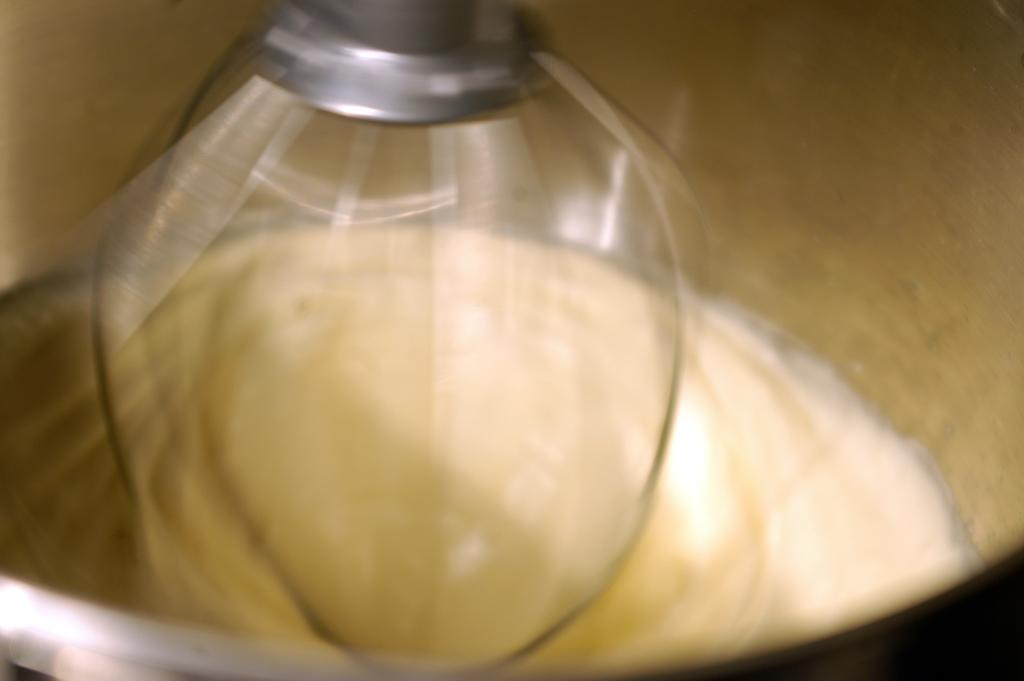What object is present in the image that is used to store energy? There is a battery in the image that is used to store energy. Where is the battery located in the image? The battery is in a bowl in the image. What tool is visible in the image that can be used for mixing or stirring? There is a stirrer in the image that can be used for mixing or stirring. What type of flower is growing in the bowl with the battery? There is no flower present in the image; it only shows a battery in a bowl and a stirrer. 